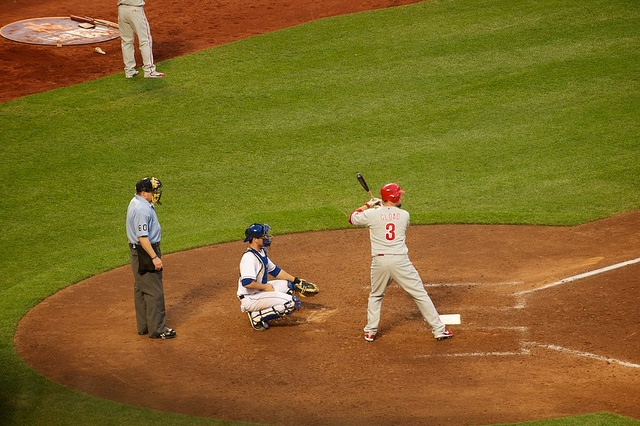Describe the objects in this image and their specific colors. I can see people in maroon, tan, and lightgray tones, people in maroon, gray, black, and darkgray tones, people in maroon, lightgray, black, navy, and gray tones, people in maroon and tan tones, and baseball glove in maroon, black, olive, and tan tones in this image. 